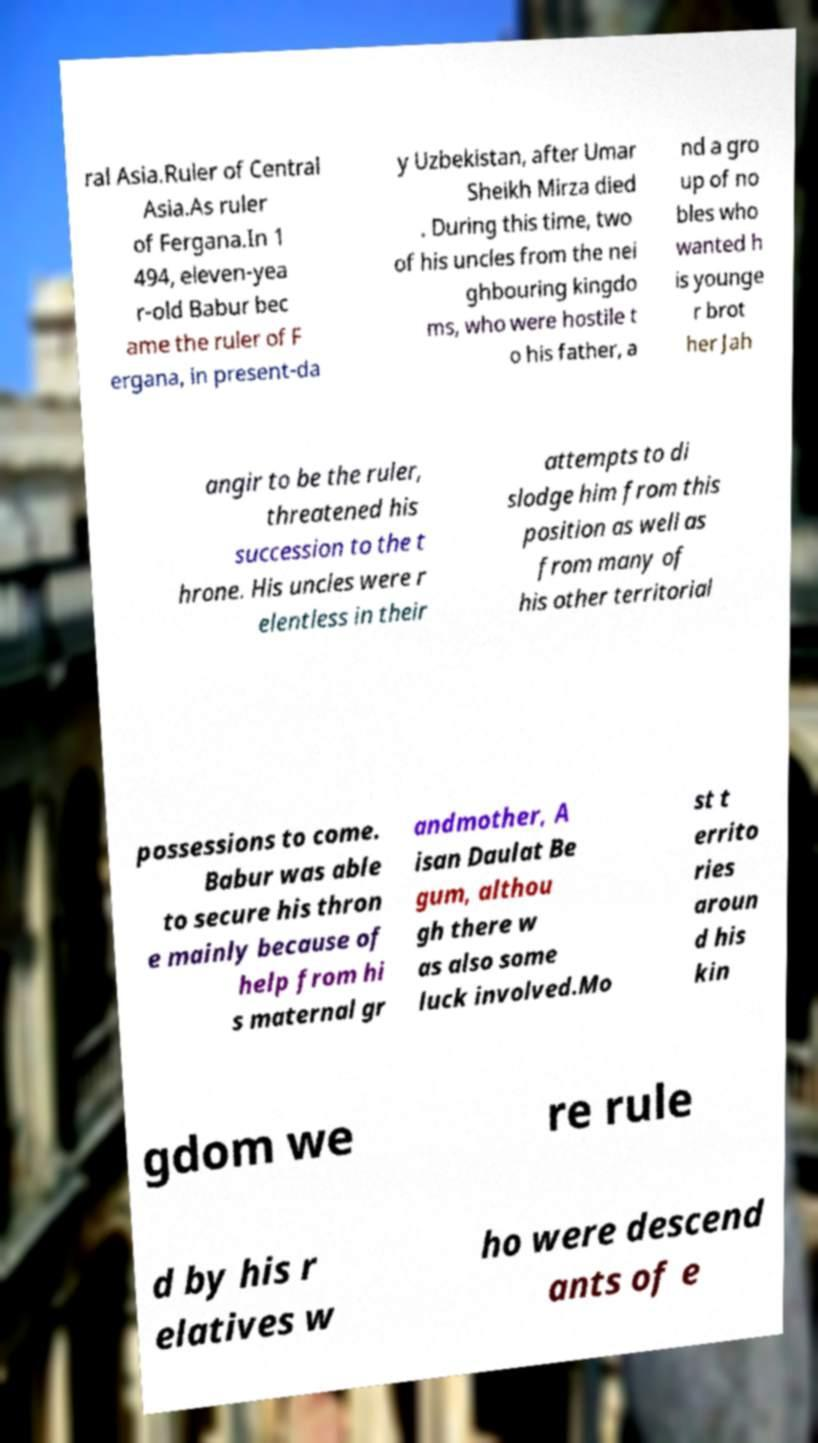I need the written content from this picture converted into text. Can you do that? ral Asia.Ruler of Central Asia.As ruler of Fergana.In 1 494, eleven-yea r-old Babur bec ame the ruler of F ergana, in present-da y Uzbekistan, after Umar Sheikh Mirza died . During this time, two of his uncles from the nei ghbouring kingdo ms, who were hostile t o his father, a nd a gro up of no bles who wanted h is younge r brot her Jah angir to be the ruler, threatened his succession to the t hrone. His uncles were r elentless in their attempts to di slodge him from this position as well as from many of his other territorial possessions to come. Babur was able to secure his thron e mainly because of help from hi s maternal gr andmother, A isan Daulat Be gum, althou gh there w as also some luck involved.Mo st t errito ries aroun d his kin gdom we re rule d by his r elatives w ho were descend ants of e 